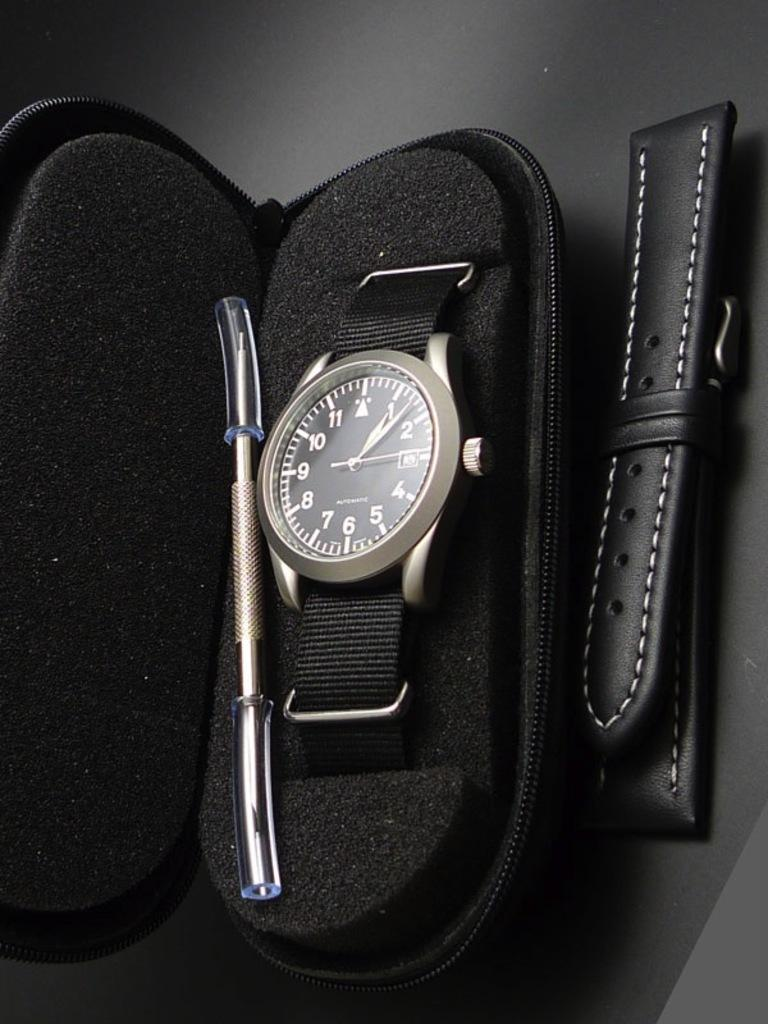What object is the main focus of the image? There is a black watch in the image. Where is the watch located? The watch is in a box. What is attached to the box? The box has a leather strap behind it. On what surface is the box placed? The box is on the floor. What type of rock can be seen in the image? There is no rock present in the image; it features a black watch in a box. How is the soap being used in the image? There is no soap present in the image. 